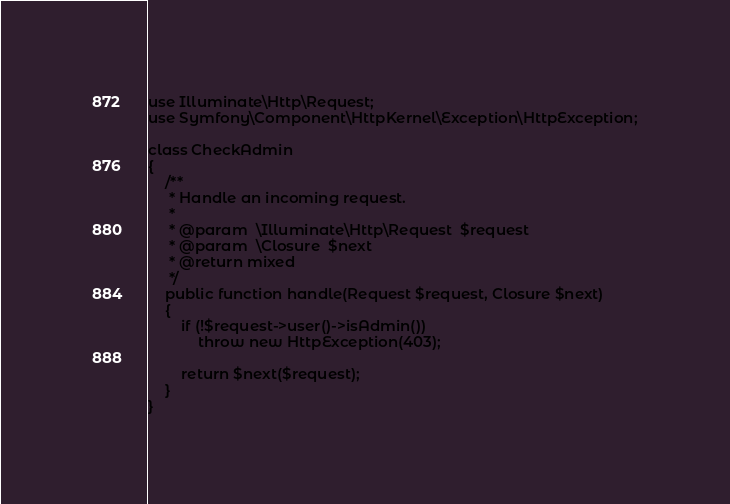Convert code to text. <code><loc_0><loc_0><loc_500><loc_500><_PHP_>use Illuminate\Http\Request;
use Symfony\Component\HttpKernel\Exception\HttpException;

class CheckAdmin
{
    /**
     * Handle an incoming request.
     *
     * @param  \Illuminate\Http\Request  $request
     * @param  \Closure  $next
     * @return mixed
     */
    public function handle(Request $request, Closure $next)
    {
        if (!$request->user()->isAdmin())
            throw new HttpException(403);

        return $next($request);
    }
}
</code> 